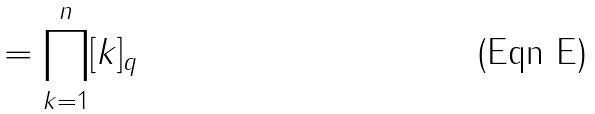<formula> <loc_0><loc_0><loc_500><loc_500>= \prod _ { k = 1 } ^ { n } [ k ] _ { q }</formula> 